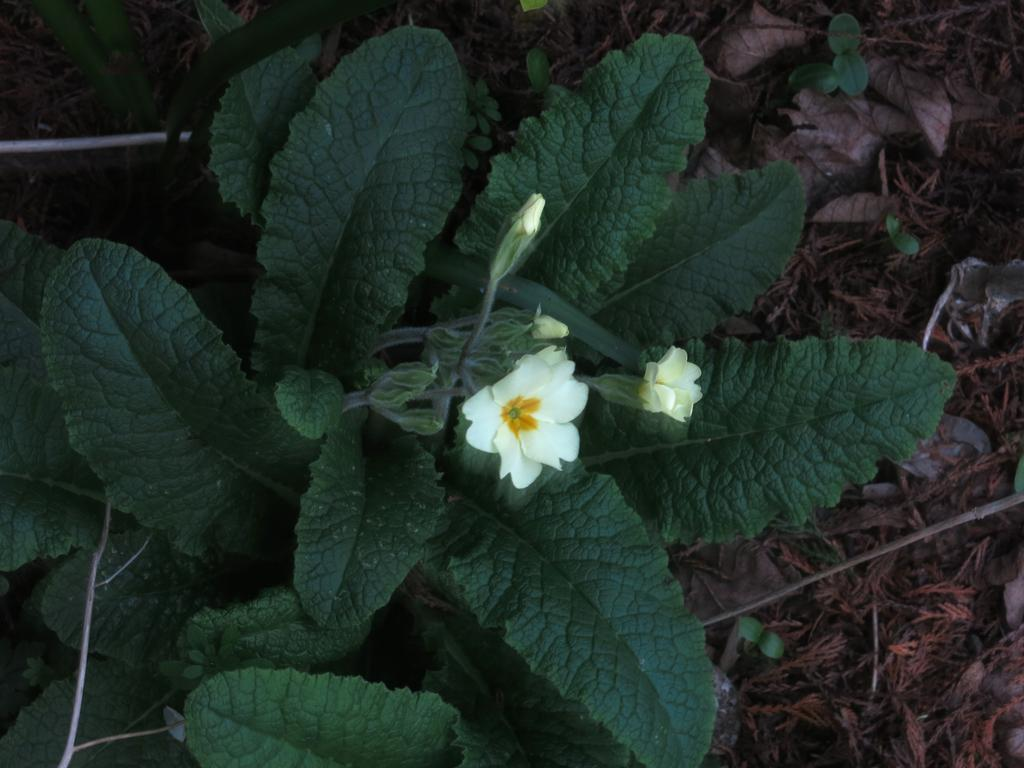What type of living organism can be seen in the image? There is a flower in the image. What else is present in the image besides the flower? There are plants in the image. Where are the flower and plants located in the image? The flower and plants are in the center of the image. What type of wrench is being used to process the flower in the image? There is no wrench or any process being performed on the flower in the image; it is simply a flower and plants in the center. 